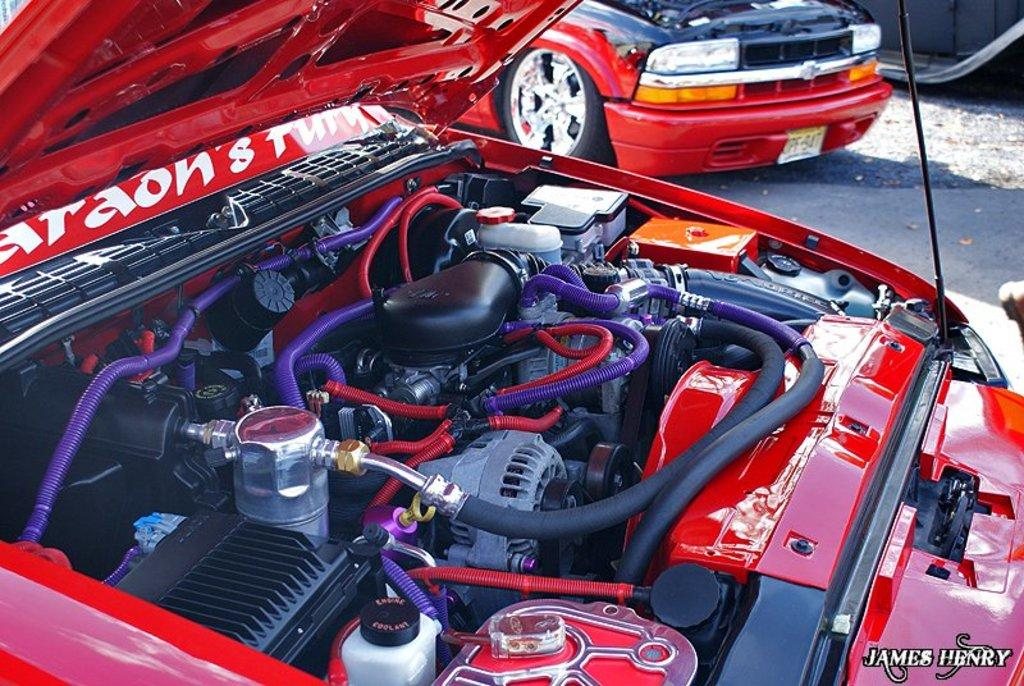What type of objects can be seen in the image? There are car engine parts visible in the image. Can you describe anything else in the image besides the engine parts? Yes, there is a red vehicle in the distance. Is there any text or marking on the image? Yes, there is a watermark at the bottom right side of the image. How many horses are visible in the image? There are no horses present in the image. What type of cloth is draped over the engine parts in the image? There is no cloth draped over the engine parts in the image; they are visible and not covered. 